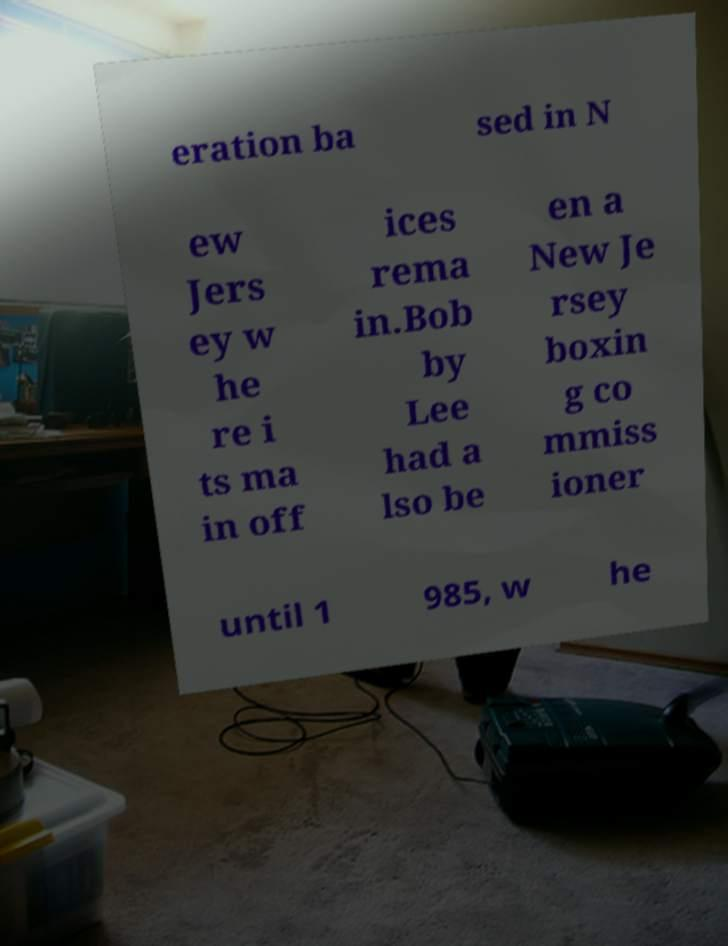Please read and relay the text visible in this image. What does it say? eration ba sed in N ew Jers ey w he re i ts ma in off ices rema in.Bob by Lee had a lso be en a New Je rsey boxin g co mmiss ioner until 1 985, w he 